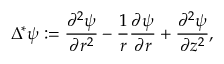<formula> <loc_0><loc_0><loc_500><loc_500>\Delta ^ { * } \psi \colon = \frac { \partial ^ { 2 } \psi } { \partial r ^ { 2 } } - \frac { 1 } { r } \frac { \partial \psi } { \partial r } + \frac { \partial ^ { 2 } \psi } { \partial z ^ { 2 } } ,</formula> 